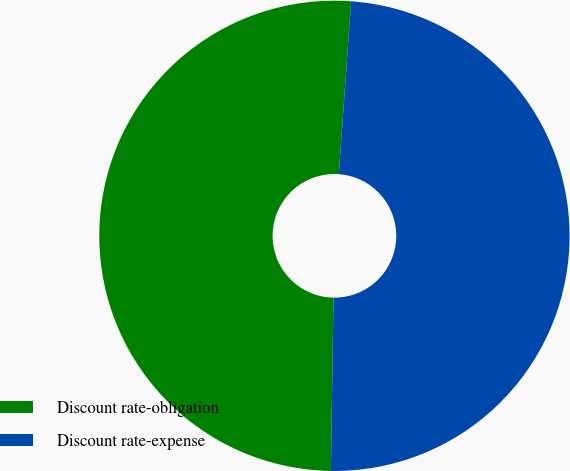Convert chart. <chart><loc_0><loc_0><loc_500><loc_500><pie_chart><fcel>Discount rate-obligation<fcel>Discount rate-expense<nl><fcel>50.89%<fcel>49.11%<nl></chart> 